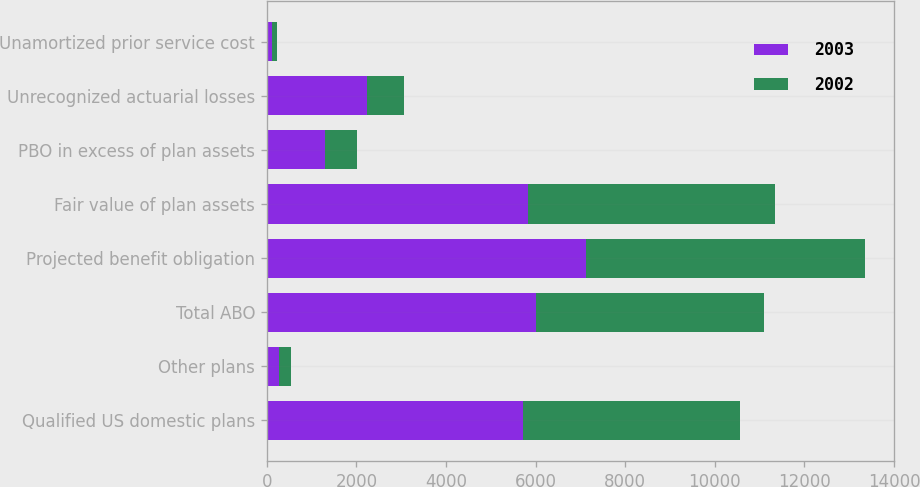Convert chart to OTSL. <chart><loc_0><loc_0><loc_500><loc_500><stacked_bar_chart><ecel><fcel>Qualified US domestic plans<fcel>Other plans<fcel>Total ABO<fcel>Projected benefit obligation<fcel>Fair value of plan assets<fcel>PBO in excess of plan assets<fcel>Unrecognized actuarial losses<fcel>Unamortized prior service cost<nl><fcel>2003<fcel>5725<fcel>284<fcel>6009<fcel>7117<fcel>5825<fcel>1292<fcel>2247<fcel>116<nl><fcel>2002<fcel>4844<fcel>253<fcel>5097<fcel>6227<fcel>5510<fcel>717<fcel>823<fcel>122<nl></chart> 